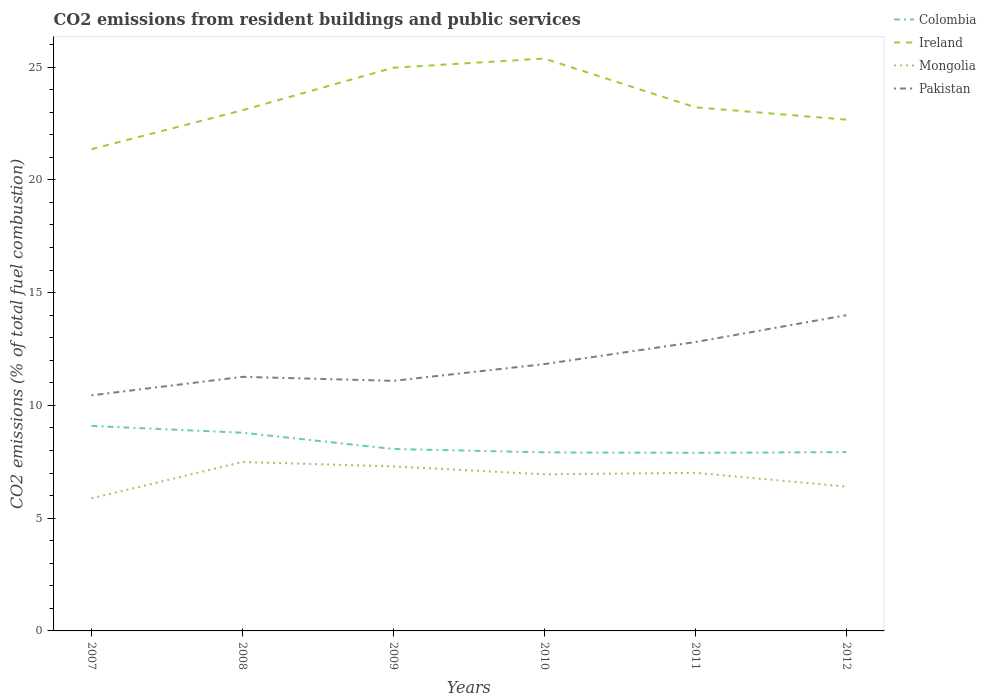How many different coloured lines are there?
Make the answer very short. 4. Does the line corresponding to Pakistan intersect with the line corresponding to Colombia?
Offer a terse response. No. Across all years, what is the maximum total CO2 emitted in Pakistan?
Your answer should be very brief. 10.45. In which year was the total CO2 emitted in Ireland maximum?
Give a very brief answer. 2007. What is the total total CO2 emitted in Colombia in the graph?
Offer a terse response. 1.02. What is the difference between the highest and the second highest total CO2 emitted in Pakistan?
Offer a terse response. 3.55. Is the total CO2 emitted in Colombia strictly greater than the total CO2 emitted in Ireland over the years?
Your answer should be compact. Yes. How many lines are there?
Make the answer very short. 4. How many years are there in the graph?
Provide a succinct answer. 6. What is the difference between two consecutive major ticks on the Y-axis?
Ensure brevity in your answer.  5. Does the graph contain any zero values?
Offer a terse response. No. Where does the legend appear in the graph?
Offer a very short reply. Top right. What is the title of the graph?
Keep it short and to the point. CO2 emissions from resident buildings and public services. What is the label or title of the Y-axis?
Your response must be concise. CO2 emissions (% of total fuel combustion). What is the CO2 emissions (% of total fuel combustion) in Colombia in 2007?
Give a very brief answer. 9.09. What is the CO2 emissions (% of total fuel combustion) of Ireland in 2007?
Give a very brief answer. 21.36. What is the CO2 emissions (% of total fuel combustion) of Mongolia in 2007?
Your response must be concise. 5.88. What is the CO2 emissions (% of total fuel combustion) in Pakistan in 2007?
Offer a very short reply. 10.45. What is the CO2 emissions (% of total fuel combustion) in Colombia in 2008?
Offer a very short reply. 8.79. What is the CO2 emissions (% of total fuel combustion) of Ireland in 2008?
Offer a very short reply. 23.09. What is the CO2 emissions (% of total fuel combustion) in Mongolia in 2008?
Provide a short and direct response. 7.49. What is the CO2 emissions (% of total fuel combustion) in Pakistan in 2008?
Your answer should be very brief. 11.27. What is the CO2 emissions (% of total fuel combustion) of Colombia in 2009?
Your answer should be very brief. 8.07. What is the CO2 emissions (% of total fuel combustion) of Ireland in 2009?
Provide a short and direct response. 24.97. What is the CO2 emissions (% of total fuel combustion) in Mongolia in 2009?
Make the answer very short. 7.3. What is the CO2 emissions (% of total fuel combustion) of Pakistan in 2009?
Make the answer very short. 11.09. What is the CO2 emissions (% of total fuel combustion) in Colombia in 2010?
Ensure brevity in your answer.  7.92. What is the CO2 emissions (% of total fuel combustion) in Ireland in 2010?
Provide a succinct answer. 25.38. What is the CO2 emissions (% of total fuel combustion) in Mongolia in 2010?
Your response must be concise. 6.94. What is the CO2 emissions (% of total fuel combustion) of Pakistan in 2010?
Your response must be concise. 11.83. What is the CO2 emissions (% of total fuel combustion) of Colombia in 2011?
Offer a terse response. 7.9. What is the CO2 emissions (% of total fuel combustion) of Ireland in 2011?
Provide a short and direct response. 23.22. What is the CO2 emissions (% of total fuel combustion) of Mongolia in 2011?
Give a very brief answer. 7.01. What is the CO2 emissions (% of total fuel combustion) in Pakistan in 2011?
Provide a succinct answer. 12.81. What is the CO2 emissions (% of total fuel combustion) in Colombia in 2012?
Your answer should be compact. 7.93. What is the CO2 emissions (% of total fuel combustion) of Ireland in 2012?
Offer a very short reply. 22.67. What is the CO2 emissions (% of total fuel combustion) in Mongolia in 2012?
Make the answer very short. 6.4. What is the CO2 emissions (% of total fuel combustion) of Pakistan in 2012?
Offer a very short reply. 14. Across all years, what is the maximum CO2 emissions (% of total fuel combustion) in Colombia?
Provide a succinct answer. 9.09. Across all years, what is the maximum CO2 emissions (% of total fuel combustion) of Ireland?
Offer a very short reply. 25.38. Across all years, what is the maximum CO2 emissions (% of total fuel combustion) of Mongolia?
Offer a terse response. 7.49. Across all years, what is the maximum CO2 emissions (% of total fuel combustion) in Pakistan?
Your response must be concise. 14. Across all years, what is the minimum CO2 emissions (% of total fuel combustion) of Colombia?
Provide a short and direct response. 7.9. Across all years, what is the minimum CO2 emissions (% of total fuel combustion) in Ireland?
Your response must be concise. 21.36. Across all years, what is the minimum CO2 emissions (% of total fuel combustion) of Mongolia?
Provide a succinct answer. 5.88. Across all years, what is the minimum CO2 emissions (% of total fuel combustion) of Pakistan?
Give a very brief answer. 10.45. What is the total CO2 emissions (% of total fuel combustion) of Colombia in the graph?
Ensure brevity in your answer.  49.69. What is the total CO2 emissions (% of total fuel combustion) in Ireland in the graph?
Offer a terse response. 140.69. What is the total CO2 emissions (% of total fuel combustion) of Mongolia in the graph?
Your answer should be very brief. 41.02. What is the total CO2 emissions (% of total fuel combustion) of Pakistan in the graph?
Your answer should be very brief. 71.44. What is the difference between the CO2 emissions (% of total fuel combustion) of Colombia in 2007 and that in 2008?
Keep it short and to the point. 0.3. What is the difference between the CO2 emissions (% of total fuel combustion) of Ireland in 2007 and that in 2008?
Keep it short and to the point. -1.73. What is the difference between the CO2 emissions (% of total fuel combustion) in Mongolia in 2007 and that in 2008?
Offer a terse response. -1.61. What is the difference between the CO2 emissions (% of total fuel combustion) in Pakistan in 2007 and that in 2008?
Offer a terse response. -0.82. What is the difference between the CO2 emissions (% of total fuel combustion) of Colombia in 2007 and that in 2009?
Your response must be concise. 1.02. What is the difference between the CO2 emissions (% of total fuel combustion) of Ireland in 2007 and that in 2009?
Provide a short and direct response. -3.61. What is the difference between the CO2 emissions (% of total fuel combustion) in Mongolia in 2007 and that in 2009?
Your response must be concise. -1.42. What is the difference between the CO2 emissions (% of total fuel combustion) of Pakistan in 2007 and that in 2009?
Provide a short and direct response. -0.64. What is the difference between the CO2 emissions (% of total fuel combustion) of Colombia in 2007 and that in 2010?
Offer a very short reply. 1.17. What is the difference between the CO2 emissions (% of total fuel combustion) in Ireland in 2007 and that in 2010?
Provide a succinct answer. -4.02. What is the difference between the CO2 emissions (% of total fuel combustion) of Mongolia in 2007 and that in 2010?
Your answer should be very brief. -1.07. What is the difference between the CO2 emissions (% of total fuel combustion) of Pakistan in 2007 and that in 2010?
Give a very brief answer. -1.38. What is the difference between the CO2 emissions (% of total fuel combustion) in Colombia in 2007 and that in 2011?
Offer a terse response. 1.19. What is the difference between the CO2 emissions (% of total fuel combustion) of Ireland in 2007 and that in 2011?
Your answer should be compact. -1.86. What is the difference between the CO2 emissions (% of total fuel combustion) of Mongolia in 2007 and that in 2011?
Your response must be concise. -1.13. What is the difference between the CO2 emissions (% of total fuel combustion) of Pakistan in 2007 and that in 2011?
Your answer should be compact. -2.36. What is the difference between the CO2 emissions (% of total fuel combustion) of Colombia in 2007 and that in 2012?
Your response must be concise. 1.16. What is the difference between the CO2 emissions (% of total fuel combustion) in Ireland in 2007 and that in 2012?
Ensure brevity in your answer.  -1.31. What is the difference between the CO2 emissions (% of total fuel combustion) in Mongolia in 2007 and that in 2012?
Offer a very short reply. -0.52. What is the difference between the CO2 emissions (% of total fuel combustion) of Pakistan in 2007 and that in 2012?
Give a very brief answer. -3.55. What is the difference between the CO2 emissions (% of total fuel combustion) of Colombia in 2008 and that in 2009?
Your response must be concise. 0.72. What is the difference between the CO2 emissions (% of total fuel combustion) in Ireland in 2008 and that in 2009?
Provide a succinct answer. -1.89. What is the difference between the CO2 emissions (% of total fuel combustion) in Mongolia in 2008 and that in 2009?
Your answer should be compact. 0.19. What is the difference between the CO2 emissions (% of total fuel combustion) in Pakistan in 2008 and that in 2009?
Ensure brevity in your answer.  0.18. What is the difference between the CO2 emissions (% of total fuel combustion) of Colombia in 2008 and that in 2010?
Give a very brief answer. 0.87. What is the difference between the CO2 emissions (% of total fuel combustion) of Ireland in 2008 and that in 2010?
Provide a succinct answer. -2.29. What is the difference between the CO2 emissions (% of total fuel combustion) of Mongolia in 2008 and that in 2010?
Offer a very short reply. 0.55. What is the difference between the CO2 emissions (% of total fuel combustion) of Pakistan in 2008 and that in 2010?
Your answer should be compact. -0.56. What is the difference between the CO2 emissions (% of total fuel combustion) of Colombia in 2008 and that in 2011?
Your answer should be very brief. 0.89. What is the difference between the CO2 emissions (% of total fuel combustion) in Ireland in 2008 and that in 2011?
Provide a succinct answer. -0.13. What is the difference between the CO2 emissions (% of total fuel combustion) in Mongolia in 2008 and that in 2011?
Your response must be concise. 0.48. What is the difference between the CO2 emissions (% of total fuel combustion) of Pakistan in 2008 and that in 2011?
Give a very brief answer. -1.54. What is the difference between the CO2 emissions (% of total fuel combustion) in Colombia in 2008 and that in 2012?
Make the answer very short. 0.86. What is the difference between the CO2 emissions (% of total fuel combustion) in Ireland in 2008 and that in 2012?
Give a very brief answer. 0.42. What is the difference between the CO2 emissions (% of total fuel combustion) in Mongolia in 2008 and that in 2012?
Your answer should be compact. 1.09. What is the difference between the CO2 emissions (% of total fuel combustion) of Pakistan in 2008 and that in 2012?
Make the answer very short. -2.73. What is the difference between the CO2 emissions (% of total fuel combustion) in Colombia in 2009 and that in 2010?
Your answer should be very brief. 0.15. What is the difference between the CO2 emissions (% of total fuel combustion) in Ireland in 2009 and that in 2010?
Your response must be concise. -0.4. What is the difference between the CO2 emissions (% of total fuel combustion) of Mongolia in 2009 and that in 2010?
Your answer should be very brief. 0.35. What is the difference between the CO2 emissions (% of total fuel combustion) of Pakistan in 2009 and that in 2010?
Provide a short and direct response. -0.74. What is the difference between the CO2 emissions (% of total fuel combustion) of Colombia in 2009 and that in 2011?
Your answer should be compact. 0.17. What is the difference between the CO2 emissions (% of total fuel combustion) of Ireland in 2009 and that in 2011?
Give a very brief answer. 1.76. What is the difference between the CO2 emissions (% of total fuel combustion) in Mongolia in 2009 and that in 2011?
Give a very brief answer. 0.29. What is the difference between the CO2 emissions (% of total fuel combustion) in Pakistan in 2009 and that in 2011?
Offer a terse response. -1.72. What is the difference between the CO2 emissions (% of total fuel combustion) of Colombia in 2009 and that in 2012?
Your answer should be very brief. 0.14. What is the difference between the CO2 emissions (% of total fuel combustion) in Ireland in 2009 and that in 2012?
Offer a very short reply. 2.3. What is the difference between the CO2 emissions (% of total fuel combustion) in Mongolia in 2009 and that in 2012?
Your answer should be compact. 0.9. What is the difference between the CO2 emissions (% of total fuel combustion) of Pakistan in 2009 and that in 2012?
Provide a succinct answer. -2.91. What is the difference between the CO2 emissions (% of total fuel combustion) in Colombia in 2010 and that in 2011?
Offer a terse response. 0.02. What is the difference between the CO2 emissions (% of total fuel combustion) in Ireland in 2010 and that in 2011?
Provide a succinct answer. 2.16. What is the difference between the CO2 emissions (% of total fuel combustion) of Mongolia in 2010 and that in 2011?
Keep it short and to the point. -0.07. What is the difference between the CO2 emissions (% of total fuel combustion) of Pakistan in 2010 and that in 2011?
Ensure brevity in your answer.  -0.98. What is the difference between the CO2 emissions (% of total fuel combustion) in Colombia in 2010 and that in 2012?
Keep it short and to the point. -0.01. What is the difference between the CO2 emissions (% of total fuel combustion) of Ireland in 2010 and that in 2012?
Your answer should be very brief. 2.71. What is the difference between the CO2 emissions (% of total fuel combustion) of Mongolia in 2010 and that in 2012?
Make the answer very short. 0.54. What is the difference between the CO2 emissions (% of total fuel combustion) of Pakistan in 2010 and that in 2012?
Ensure brevity in your answer.  -2.17. What is the difference between the CO2 emissions (% of total fuel combustion) in Colombia in 2011 and that in 2012?
Your answer should be very brief. -0.03. What is the difference between the CO2 emissions (% of total fuel combustion) of Ireland in 2011 and that in 2012?
Your response must be concise. 0.55. What is the difference between the CO2 emissions (% of total fuel combustion) of Mongolia in 2011 and that in 2012?
Provide a short and direct response. 0.61. What is the difference between the CO2 emissions (% of total fuel combustion) of Pakistan in 2011 and that in 2012?
Your answer should be very brief. -1.19. What is the difference between the CO2 emissions (% of total fuel combustion) in Colombia in 2007 and the CO2 emissions (% of total fuel combustion) in Ireland in 2008?
Keep it short and to the point. -14. What is the difference between the CO2 emissions (% of total fuel combustion) in Colombia in 2007 and the CO2 emissions (% of total fuel combustion) in Mongolia in 2008?
Provide a short and direct response. 1.6. What is the difference between the CO2 emissions (% of total fuel combustion) of Colombia in 2007 and the CO2 emissions (% of total fuel combustion) of Pakistan in 2008?
Make the answer very short. -2.18. What is the difference between the CO2 emissions (% of total fuel combustion) in Ireland in 2007 and the CO2 emissions (% of total fuel combustion) in Mongolia in 2008?
Provide a succinct answer. 13.87. What is the difference between the CO2 emissions (% of total fuel combustion) of Ireland in 2007 and the CO2 emissions (% of total fuel combustion) of Pakistan in 2008?
Provide a short and direct response. 10.09. What is the difference between the CO2 emissions (% of total fuel combustion) of Mongolia in 2007 and the CO2 emissions (% of total fuel combustion) of Pakistan in 2008?
Make the answer very short. -5.39. What is the difference between the CO2 emissions (% of total fuel combustion) in Colombia in 2007 and the CO2 emissions (% of total fuel combustion) in Ireland in 2009?
Keep it short and to the point. -15.89. What is the difference between the CO2 emissions (% of total fuel combustion) of Colombia in 2007 and the CO2 emissions (% of total fuel combustion) of Mongolia in 2009?
Your answer should be very brief. 1.79. What is the difference between the CO2 emissions (% of total fuel combustion) in Colombia in 2007 and the CO2 emissions (% of total fuel combustion) in Pakistan in 2009?
Provide a short and direct response. -2. What is the difference between the CO2 emissions (% of total fuel combustion) of Ireland in 2007 and the CO2 emissions (% of total fuel combustion) of Mongolia in 2009?
Make the answer very short. 14.06. What is the difference between the CO2 emissions (% of total fuel combustion) in Ireland in 2007 and the CO2 emissions (% of total fuel combustion) in Pakistan in 2009?
Ensure brevity in your answer.  10.27. What is the difference between the CO2 emissions (% of total fuel combustion) of Mongolia in 2007 and the CO2 emissions (% of total fuel combustion) of Pakistan in 2009?
Your answer should be very brief. -5.21. What is the difference between the CO2 emissions (% of total fuel combustion) in Colombia in 2007 and the CO2 emissions (% of total fuel combustion) in Ireland in 2010?
Provide a succinct answer. -16.29. What is the difference between the CO2 emissions (% of total fuel combustion) of Colombia in 2007 and the CO2 emissions (% of total fuel combustion) of Mongolia in 2010?
Your response must be concise. 2.15. What is the difference between the CO2 emissions (% of total fuel combustion) in Colombia in 2007 and the CO2 emissions (% of total fuel combustion) in Pakistan in 2010?
Your answer should be compact. -2.74. What is the difference between the CO2 emissions (% of total fuel combustion) of Ireland in 2007 and the CO2 emissions (% of total fuel combustion) of Mongolia in 2010?
Offer a terse response. 14.42. What is the difference between the CO2 emissions (% of total fuel combustion) of Ireland in 2007 and the CO2 emissions (% of total fuel combustion) of Pakistan in 2010?
Ensure brevity in your answer.  9.53. What is the difference between the CO2 emissions (% of total fuel combustion) in Mongolia in 2007 and the CO2 emissions (% of total fuel combustion) in Pakistan in 2010?
Your response must be concise. -5.95. What is the difference between the CO2 emissions (% of total fuel combustion) in Colombia in 2007 and the CO2 emissions (% of total fuel combustion) in Ireland in 2011?
Offer a very short reply. -14.13. What is the difference between the CO2 emissions (% of total fuel combustion) in Colombia in 2007 and the CO2 emissions (% of total fuel combustion) in Mongolia in 2011?
Your response must be concise. 2.08. What is the difference between the CO2 emissions (% of total fuel combustion) of Colombia in 2007 and the CO2 emissions (% of total fuel combustion) of Pakistan in 2011?
Give a very brief answer. -3.72. What is the difference between the CO2 emissions (% of total fuel combustion) in Ireland in 2007 and the CO2 emissions (% of total fuel combustion) in Mongolia in 2011?
Provide a succinct answer. 14.35. What is the difference between the CO2 emissions (% of total fuel combustion) in Ireland in 2007 and the CO2 emissions (% of total fuel combustion) in Pakistan in 2011?
Offer a terse response. 8.55. What is the difference between the CO2 emissions (% of total fuel combustion) in Mongolia in 2007 and the CO2 emissions (% of total fuel combustion) in Pakistan in 2011?
Keep it short and to the point. -6.93. What is the difference between the CO2 emissions (% of total fuel combustion) in Colombia in 2007 and the CO2 emissions (% of total fuel combustion) in Ireland in 2012?
Your answer should be very brief. -13.58. What is the difference between the CO2 emissions (% of total fuel combustion) of Colombia in 2007 and the CO2 emissions (% of total fuel combustion) of Mongolia in 2012?
Offer a very short reply. 2.69. What is the difference between the CO2 emissions (% of total fuel combustion) in Colombia in 2007 and the CO2 emissions (% of total fuel combustion) in Pakistan in 2012?
Provide a short and direct response. -4.91. What is the difference between the CO2 emissions (% of total fuel combustion) of Ireland in 2007 and the CO2 emissions (% of total fuel combustion) of Mongolia in 2012?
Provide a succinct answer. 14.96. What is the difference between the CO2 emissions (% of total fuel combustion) of Ireland in 2007 and the CO2 emissions (% of total fuel combustion) of Pakistan in 2012?
Your response must be concise. 7.36. What is the difference between the CO2 emissions (% of total fuel combustion) in Mongolia in 2007 and the CO2 emissions (% of total fuel combustion) in Pakistan in 2012?
Your response must be concise. -8.12. What is the difference between the CO2 emissions (% of total fuel combustion) in Colombia in 2008 and the CO2 emissions (% of total fuel combustion) in Ireland in 2009?
Provide a short and direct response. -16.19. What is the difference between the CO2 emissions (% of total fuel combustion) in Colombia in 2008 and the CO2 emissions (% of total fuel combustion) in Mongolia in 2009?
Your answer should be compact. 1.49. What is the difference between the CO2 emissions (% of total fuel combustion) in Colombia in 2008 and the CO2 emissions (% of total fuel combustion) in Pakistan in 2009?
Ensure brevity in your answer.  -2.3. What is the difference between the CO2 emissions (% of total fuel combustion) in Ireland in 2008 and the CO2 emissions (% of total fuel combustion) in Mongolia in 2009?
Offer a terse response. 15.79. What is the difference between the CO2 emissions (% of total fuel combustion) of Ireland in 2008 and the CO2 emissions (% of total fuel combustion) of Pakistan in 2009?
Ensure brevity in your answer.  12. What is the difference between the CO2 emissions (% of total fuel combustion) of Mongolia in 2008 and the CO2 emissions (% of total fuel combustion) of Pakistan in 2009?
Offer a very short reply. -3.6. What is the difference between the CO2 emissions (% of total fuel combustion) of Colombia in 2008 and the CO2 emissions (% of total fuel combustion) of Ireland in 2010?
Give a very brief answer. -16.59. What is the difference between the CO2 emissions (% of total fuel combustion) in Colombia in 2008 and the CO2 emissions (% of total fuel combustion) in Mongolia in 2010?
Provide a succinct answer. 1.85. What is the difference between the CO2 emissions (% of total fuel combustion) in Colombia in 2008 and the CO2 emissions (% of total fuel combustion) in Pakistan in 2010?
Your response must be concise. -3.04. What is the difference between the CO2 emissions (% of total fuel combustion) of Ireland in 2008 and the CO2 emissions (% of total fuel combustion) of Mongolia in 2010?
Provide a short and direct response. 16.14. What is the difference between the CO2 emissions (% of total fuel combustion) of Ireland in 2008 and the CO2 emissions (% of total fuel combustion) of Pakistan in 2010?
Offer a very short reply. 11.26. What is the difference between the CO2 emissions (% of total fuel combustion) in Mongolia in 2008 and the CO2 emissions (% of total fuel combustion) in Pakistan in 2010?
Keep it short and to the point. -4.34. What is the difference between the CO2 emissions (% of total fuel combustion) of Colombia in 2008 and the CO2 emissions (% of total fuel combustion) of Ireland in 2011?
Make the answer very short. -14.43. What is the difference between the CO2 emissions (% of total fuel combustion) of Colombia in 2008 and the CO2 emissions (% of total fuel combustion) of Mongolia in 2011?
Your answer should be very brief. 1.78. What is the difference between the CO2 emissions (% of total fuel combustion) of Colombia in 2008 and the CO2 emissions (% of total fuel combustion) of Pakistan in 2011?
Offer a terse response. -4.02. What is the difference between the CO2 emissions (% of total fuel combustion) of Ireland in 2008 and the CO2 emissions (% of total fuel combustion) of Mongolia in 2011?
Provide a short and direct response. 16.08. What is the difference between the CO2 emissions (% of total fuel combustion) of Ireland in 2008 and the CO2 emissions (% of total fuel combustion) of Pakistan in 2011?
Provide a succinct answer. 10.28. What is the difference between the CO2 emissions (% of total fuel combustion) in Mongolia in 2008 and the CO2 emissions (% of total fuel combustion) in Pakistan in 2011?
Offer a very short reply. -5.32. What is the difference between the CO2 emissions (% of total fuel combustion) of Colombia in 2008 and the CO2 emissions (% of total fuel combustion) of Ireland in 2012?
Your answer should be compact. -13.88. What is the difference between the CO2 emissions (% of total fuel combustion) of Colombia in 2008 and the CO2 emissions (% of total fuel combustion) of Mongolia in 2012?
Offer a terse response. 2.39. What is the difference between the CO2 emissions (% of total fuel combustion) in Colombia in 2008 and the CO2 emissions (% of total fuel combustion) in Pakistan in 2012?
Offer a very short reply. -5.21. What is the difference between the CO2 emissions (% of total fuel combustion) in Ireland in 2008 and the CO2 emissions (% of total fuel combustion) in Mongolia in 2012?
Give a very brief answer. 16.69. What is the difference between the CO2 emissions (% of total fuel combustion) of Ireland in 2008 and the CO2 emissions (% of total fuel combustion) of Pakistan in 2012?
Offer a very short reply. 9.09. What is the difference between the CO2 emissions (% of total fuel combustion) of Mongolia in 2008 and the CO2 emissions (% of total fuel combustion) of Pakistan in 2012?
Provide a succinct answer. -6.51. What is the difference between the CO2 emissions (% of total fuel combustion) of Colombia in 2009 and the CO2 emissions (% of total fuel combustion) of Ireland in 2010?
Offer a terse response. -17.31. What is the difference between the CO2 emissions (% of total fuel combustion) in Colombia in 2009 and the CO2 emissions (% of total fuel combustion) in Mongolia in 2010?
Give a very brief answer. 1.12. What is the difference between the CO2 emissions (% of total fuel combustion) of Colombia in 2009 and the CO2 emissions (% of total fuel combustion) of Pakistan in 2010?
Keep it short and to the point. -3.76. What is the difference between the CO2 emissions (% of total fuel combustion) in Ireland in 2009 and the CO2 emissions (% of total fuel combustion) in Mongolia in 2010?
Ensure brevity in your answer.  18.03. What is the difference between the CO2 emissions (% of total fuel combustion) of Ireland in 2009 and the CO2 emissions (% of total fuel combustion) of Pakistan in 2010?
Keep it short and to the point. 13.14. What is the difference between the CO2 emissions (% of total fuel combustion) in Mongolia in 2009 and the CO2 emissions (% of total fuel combustion) in Pakistan in 2010?
Make the answer very short. -4.53. What is the difference between the CO2 emissions (% of total fuel combustion) in Colombia in 2009 and the CO2 emissions (% of total fuel combustion) in Ireland in 2011?
Ensure brevity in your answer.  -15.15. What is the difference between the CO2 emissions (% of total fuel combustion) in Colombia in 2009 and the CO2 emissions (% of total fuel combustion) in Mongolia in 2011?
Your response must be concise. 1.06. What is the difference between the CO2 emissions (% of total fuel combustion) of Colombia in 2009 and the CO2 emissions (% of total fuel combustion) of Pakistan in 2011?
Give a very brief answer. -4.74. What is the difference between the CO2 emissions (% of total fuel combustion) of Ireland in 2009 and the CO2 emissions (% of total fuel combustion) of Mongolia in 2011?
Provide a succinct answer. 17.96. What is the difference between the CO2 emissions (% of total fuel combustion) in Ireland in 2009 and the CO2 emissions (% of total fuel combustion) in Pakistan in 2011?
Provide a succinct answer. 12.17. What is the difference between the CO2 emissions (% of total fuel combustion) of Mongolia in 2009 and the CO2 emissions (% of total fuel combustion) of Pakistan in 2011?
Your answer should be compact. -5.51. What is the difference between the CO2 emissions (% of total fuel combustion) in Colombia in 2009 and the CO2 emissions (% of total fuel combustion) in Ireland in 2012?
Your answer should be compact. -14.6. What is the difference between the CO2 emissions (% of total fuel combustion) of Colombia in 2009 and the CO2 emissions (% of total fuel combustion) of Mongolia in 2012?
Offer a terse response. 1.67. What is the difference between the CO2 emissions (% of total fuel combustion) in Colombia in 2009 and the CO2 emissions (% of total fuel combustion) in Pakistan in 2012?
Provide a short and direct response. -5.93. What is the difference between the CO2 emissions (% of total fuel combustion) in Ireland in 2009 and the CO2 emissions (% of total fuel combustion) in Mongolia in 2012?
Ensure brevity in your answer.  18.58. What is the difference between the CO2 emissions (% of total fuel combustion) in Ireland in 2009 and the CO2 emissions (% of total fuel combustion) in Pakistan in 2012?
Your answer should be compact. 10.98. What is the difference between the CO2 emissions (% of total fuel combustion) in Mongolia in 2009 and the CO2 emissions (% of total fuel combustion) in Pakistan in 2012?
Your response must be concise. -6.7. What is the difference between the CO2 emissions (% of total fuel combustion) of Colombia in 2010 and the CO2 emissions (% of total fuel combustion) of Ireland in 2011?
Offer a very short reply. -15.3. What is the difference between the CO2 emissions (% of total fuel combustion) of Colombia in 2010 and the CO2 emissions (% of total fuel combustion) of Mongolia in 2011?
Offer a terse response. 0.91. What is the difference between the CO2 emissions (% of total fuel combustion) of Colombia in 2010 and the CO2 emissions (% of total fuel combustion) of Pakistan in 2011?
Offer a very short reply. -4.89. What is the difference between the CO2 emissions (% of total fuel combustion) in Ireland in 2010 and the CO2 emissions (% of total fuel combustion) in Mongolia in 2011?
Provide a short and direct response. 18.37. What is the difference between the CO2 emissions (% of total fuel combustion) in Ireland in 2010 and the CO2 emissions (% of total fuel combustion) in Pakistan in 2011?
Give a very brief answer. 12.57. What is the difference between the CO2 emissions (% of total fuel combustion) in Mongolia in 2010 and the CO2 emissions (% of total fuel combustion) in Pakistan in 2011?
Your response must be concise. -5.87. What is the difference between the CO2 emissions (% of total fuel combustion) in Colombia in 2010 and the CO2 emissions (% of total fuel combustion) in Ireland in 2012?
Ensure brevity in your answer.  -14.75. What is the difference between the CO2 emissions (% of total fuel combustion) of Colombia in 2010 and the CO2 emissions (% of total fuel combustion) of Mongolia in 2012?
Your response must be concise. 1.52. What is the difference between the CO2 emissions (% of total fuel combustion) of Colombia in 2010 and the CO2 emissions (% of total fuel combustion) of Pakistan in 2012?
Provide a short and direct response. -6.08. What is the difference between the CO2 emissions (% of total fuel combustion) of Ireland in 2010 and the CO2 emissions (% of total fuel combustion) of Mongolia in 2012?
Ensure brevity in your answer.  18.98. What is the difference between the CO2 emissions (% of total fuel combustion) in Ireland in 2010 and the CO2 emissions (% of total fuel combustion) in Pakistan in 2012?
Offer a very short reply. 11.38. What is the difference between the CO2 emissions (% of total fuel combustion) in Mongolia in 2010 and the CO2 emissions (% of total fuel combustion) in Pakistan in 2012?
Your answer should be very brief. -7.06. What is the difference between the CO2 emissions (% of total fuel combustion) of Colombia in 2011 and the CO2 emissions (% of total fuel combustion) of Ireland in 2012?
Your answer should be compact. -14.77. What is the difference between the CO2 emissions (% of total fuel combustion) of Colombia in 2011 and the CO2 emissions (% of total fuel combustion) of Mongolia in 2012?
Offer a terse response. 1.5. What is the difference between the CO2 emissions (% of total fuel combustion) in Colombia in 2011 and the CO2 emissions (% of total fuel combustion) in Pakistan in 2012?
Your answer should be very brief. -6.1. What is the difference between the CO2 emissions (% of total fuel combustion) in Ireland in 2011 and the CO2 emissions (% of total fuel combustion) in Mongolia in 2012?
Your answer should be very brief. 16.82. What is the difference between the CO2 emissions (% of total fuel combustion) of Ireland in 2011 and the CO2 emissions (% of total fuel combustion) of Pakistan in 2012?
Offer a terse response. 9.22. What is the difference between the CO2 emissions (% of total fuel combustion) in Mongolia in 2011 and the CO2 emissions (% of total fuel combustion) in Pakistan in 2012?
Give a very brief answer. -6.99. What is the average CO2 emissions (% of total fuel combustion) in Colombia per year?
Provide a succinct answer. 8.28. What is the average CO2 emissions (% of total fuel combustion) in Ireland per year?
Your response must be concise. 23.45. What is the average CO2 emissions (% of total fuel combustion) of Mongolia per year?
Your response must be concise. 6.84. What is the average CO2 emissions (% of total fuel combustion) in Pakistan per year?
Give a very brief answer. 11.91. In the year 2007, what is the difference between the CO2 emissions (% of total fuel combustion) in Colombia and CO2 emissions (% of total fuel combustion) in Ireland?
Offer a very short reply. -12.27. In the year 2007, what is the difference between the CO2 emissions (% of total fuel combustion) in Colombia and CO2 emissions (% of total fuel combustion) in Mongolia?
Provide a short and direct response. 3.21. In the year 2007, what is the difference between the CO2 emissions (% of total fuel combustion) in Colombia and CO2 emissions (% of total fuel combustion) in Pakistan?
Your answer should be compact. -1.36. In the year 2007, what is the difference between the CO2 emissions (% of total fuel combustion) in Ireland and CO2 emissions (% of total fuel combustion) in Mongolia?
Make the answer very short. 15.48. In the year 2007, what is the difference between the CO2 emissions (% of total fuel combustion) in Ireland and CO2 emissions (% of total fuel combustion) in Pakistan?
Offer a very short reply. 10.91. In the year 2007, what is the difference between the CO2 emissions (% of total fuel combustion) of Mongolia and CO2 emissions (% of total fuel combustion) of Pakistan?
Ensure brevity in your answer.  -4.57. In the year 2008, what is the difference between the CO2 emissions (% of total fuel combustion) in Colombia and CO2 emissions (% of total fuel combustion) in Ireland?
Provide a short and direct response. -14.3. In the year 2008, what is the difference between the CO2 emissions (% of total fuel combustion) in Colombia and CO2 emissions (% of total fuel combustion) in Mongolia?
Your answer should be compact. 1.3. In the year 2008, what is the difference between the CO2 emissions (% of total fuel combustion) in Colombia and CO2 emissions (% of total fuel combustion) in Pakistan?
Your answer should be compact. -2.48. In the year 2008, what is the difference between the CO2 emissions (% of total fuel combustion) of Ireland and CO2 emissions (% of total fuel combustion) of Mongolia?
Provide a short and direct response. 15.6. In the year 2008, what is the difference between the CO2 emissions (% of total fuel combustion) of Ireland and CO2 emissions (% of total fuel combustion) of Pakistan?
Your response must be concise. 11.82. In the year 2008, what is the difference between the CO2 emissions (% of total fuel combustion) of Mongolia and CO2 emissions (% of total fuel combustion) of Pakistan?
Your answer should be very brief. -3.78. In the year 2009, what is the difference between the CO2 emissions (% of total fuel combustion) of Colombia and CO2 emissions (% of total fuel combustion) of Ireland?
Your answer should be compact. -16.91. In the year 2009, what is the difference between the CO2 emissions (% of total fuel combustion) in Colombia and CO2 emissions (% of total fuel combustion) in Mongolia?
Your answer should be compact. 0.77. In the year 2009, what is the difference between the CO2 emissions (% of total fuel combustion) in Colombia and CO2 emissions (% of total fuel combustion) in Pakistan?
Your response must be concise. -3.02. In the year 2009, what is the difference between the CO2 emissions (% of total fuel combustion) of Ireland and CO2 emissions (% of total fuel combustion) of Mongolia?
Provide a succinct answer. 17.68. In the year 2009, what is the difference between the CO2 emissions (% of total fuel combustion) of Ireland and CO2 emissions (% of total fuel combustion) of Pakistan?
Your answer should be very brief. 13.88. In the year 2009, what is the difference between the CO2 emissions (% of total fuel combustion) of Mongolia and CO2 emissions (% of total fuel combustion) of Pakistan?
Make the answer very short. -3.79. In the year 2010, what is the difference between the CO2 emissions (% of total fuel combustion) of Colombia and CO2 emissions (% of total fuel combustion) of Ireland?
Offer a terse response. -17.46. In the year 2010, what is the difference between the CO2 emissions (% of total fuel combustion) of Colombia and CO2 emissions (% of total fuel combustion) of Mongolia?
Offer a terse response. 0.97. In the year 2010, what is the difference between the CO2 emissions (% of total fuel combustion) of Colombia and CO2 emissions (% of total fuel combustion) of Pakistan?
Make the answer very short. -3.91. In the year 2010, what is the difference between the CO2 emissions (% of total fuel combustion) of Ireland and CO2 emissions (% of total fuel combustion) of Mongolia?
Offer a very short reply. 18.44. In the year 2010, what is the difference between the CO2 emissions (% of total fuel combustion) of Ireland and CO2 emissions (% of total fuel combustion) of Pakistan?
Offer a very short reply. 13.55. In the year 2010, what is the difference between the CO2 emissions (% of total fuel combustion) in Mongolia and CO2 emissions (% of total fuel combustion) in Pakistan?
Offer a very short reply. -4.89. In the year 2011, what is the difference between the CO2 emissions (% of total fuel combustion) in Colombia and CO2 emissions (% of total fuel combustion) in Ireland?
Your response must be concise. -15.32. In the year 2011, what is the difference between the CO2 emissions (% of total fuel combustion) of Colombia and CO2 emissions (% of total fuel combustion) of Mongolia?
Offer a very short reply. 0.89. In the year 2011, what is the difference between the CO2 emissions (% of total fuel combustion) of Colombia and CO2 emissions (% of total fuel combustion) of Pakistan?
Make the answer very short. -4.91. In the year 2011, what is the difference between the CO2 emissions (% of total fuel combustion) of Ireland and CO2 emissions (% of total fuel combustion) of Mongolia?
Keep it short and to the point. 16.21. In the year 2011, what is the difference between the CO2 emissions (% of total fuel combustion) of Ireland and CO2 emissions (% of total fuel combustion) of Pakistan?
Ensure brevity in your answer.  10.41. In the year 2011, what is the difference between the CO2 emissions (% of total fuel combustion) in Mongolia and CO2 emissions (% of total fuel combustion) in Pakistan?
Offer a very short reply. -5.8. In the year 2012, what is the difference between the CO2 emissions (% of total fuel combustion) of Colombia and CO2 emissions (% of total fuel combustion) of Ireland?
Your answer should be very brief. -14.74. In the year 2012, what is the difference between the CO2 emissions (% of total fuel combustion) of Colombia and CO2 emissions (% of total fuel combustion) of Mongolia?
Offer a terse response. 1.53. In the year 2012, what is the difference between the CO2 emissions (% of total fuel combustion) of Colombia and CO2 emissions (% of total fuel combustion) of Pakistan?
Give a very brief answer. -6.07. In the year 2012, what is the difference between the CO2 emissions (% of total fuel combustion) in Ireland and CO2 emissions (% of total fuel combustion) in Mongolia?
Provide a succinct answer. 16.27. In the year 2012, what is the difference between the CO2 emissions (% of total fuel combustion) in Ireland and CO2 emissions (% of total fuel combustion) in Pakistan?
Give a very brief answer. 8.67. In the year 2012, what is the difference between the CO2 emissions (% of total fuel combustion) of Mongolia and CO2 emissions (% of total fuel combustion) of Pakistan?
Offer a terse response. -7.6. What is the ratio of the CO2 emissions (% of total fuel combustion) in Colombia in 2007 to that in 2008?
Make the answer very short. 1.03. What is the ratio of the CO2 emissions (% of total fuel combustion) of Ireland in 2007 to that in 2008?
Offer a terse response. 0.93. What is the ratio of the CO2 emissions (% of total fuel combustion) of Mongolia in 2007 to that in 2008?
Keep it short and to the point. 0.78. What is the ratio of the CO2 emissions (% of total fuel combustion) in Pakistan in 2007 to that in 2008?
Provide a short and direct response. 0.93. What is the ratio of the CO2 emissions (% of total fuel combustion) in Colombia in 2007 to that in 2009?
Offer a terse response. 1.13. What is the ratio of the CO2 emissions (% of total fuel combustion) of Ireland in 2007 to that in 2009?
Your answer should be compact. 0.86. What is the ratio of the CO2 emissions (% of total fuel combustion) of Mongolia in 2007 to that in 2009?
Your answer should be very brief. 0.81. What is the ratio of the CO2 emissions (% of total fuel combustion) of Pakistan in 2007 to that in 2009?
Keep it short and to the point. 0.94. What is the ratio of the CO2 emissions (% of total fuel combustion) in Colombia in 2007 to that in 2010?
Your answer should be very brief. 1.15. What is the ratio of the CO2 emissions (% of total fuel combustion) of Ireland in 2007 to that in 2010?
Keep it short and to the point. 0.84. What is the ratio of the CO2 emissions (% of total fuel combustion) of Mongolia in 2007 to that in 2010?
Offer a terse response. 0.85. What is the ratio of the CO2 emissions (% of total fuel combustion) in Pakistan in 2007 to that in 2010?
Keep it short and to the point. 0.88. What is the ratio of the CO2 emissions (% of total fuel combustion) in Colombia in 2007 to that in 2011?
Your response must be concise. 1.15. What is the ratio of the CO2 emissions (% of total fuel combustion) of Ireland in 2007 to that in 2011?
Your answer should be compact. 0.92. What is the ratio of the CO2 emissions (% of total fuel combustion) in Mongolia in 2007 to that in 2011?
Provide a succinct answer. 0.84. What is the ratio of the CO2 emissions (% of total fuel combustion) of Pakistan in 2007 to that in 2011?
Your answer should be very brief. 0.82. What is the ratio of the CO2 emissions (% of total fuel combustion) of Colombia in 2007 to that in 2012?
Keep it short and to the point. 1.15. What is the ratio of the CO2 emissions (% of total fuel combustion) in Ireland in 2007 to that in 2012?
Make the answer very short. 0.94. What is the ratio of the CO2 emissions (% of total fuel combustion) in Mongolia in 2007 to that in 2012?
Ensure brevity in your answer.  0.92. What is the ratio of the CO2 emissions (% of total fuel combustion) in Pakistan in 2007 to that in 2012?
Offer a terse response. 0.75. What is the ratio of the CO2 emissions (% of total fuel combustion) in Colombia in 2008 to that in 2009?
Your answer should be very brief. 1.09. What is the ratio of the CO2 emissions (% of total fuel combustion) in Ireland in 2008 to that in 2009?
Your answer should be compact. 0.92. What is the ratio of the CO2 emissions (% of total fuel combustion) in Mongolia in 2008 to that in 2009?
Your answer should be compact. 1.03. What is the ratio of the CO2 emissions (% of total fuel combustion) in Pakistan in 2008 to that in 2009?
Provide a succinct answer. 1.02. What is the ratio of the CO2 emissions (% of total fuel combustion) in Colombia in 2008 to that in 2010?
Your answer should be very brief. 1.11. What is the ratio of the CO2 emissions (% of total fuel combustion) in Ireland in 2008 to that in 2010?
Ensure brevity in your answer.  0.91. What is the ratio of the CO2 emissions (% of total fuel combustion) in Mongolia in 2008 to that in 2010?
Make the answer very short. 1.08. What is the ratio of the CO2 emissions (% of total fuel combustion) of Pakistan in 2008 to that in 2010?
Make the answer very short. 0.95. What is the ratio of the CO2 emissions (% of total fuel combustion) of Colombia in 2008 to that in 2011?
Your response must be concise. 1.11. What is the ratio of the CO2 emissions (% of total fuel combustion) of Ireland in 2008 to that in 2011?
Keep it short and to the point. 0.99. What is the ratio of the CO2 emissions (% of total fuel combustion) in Mongolia in 2008 to that in 2011?
Keep it short and to the point. 1.07. What is the ratio of the CO2 emissions (% of total fuel combustion) in Pakistan in 2008 to that in 2011?
Keep it short and to the point. 0.88. What is the ratio of the CO2 emissions (% of total fuel combustion) in Colombia in 2008 to that in 2012?
Provide a succinct answer. 1.11. What is the ratio of the CO2 emissions (% of total fuel combustion) of Ireland in 2008 to that in 2012?
Make the answer very short. 1.02. What is the ratio of the CO2 emissions (% of total fuel combustion) of Mongolia in 2008 to that in 2012?
Provide a succinct answer. 1.17. What is the ratio of the CO2 emissions (% of total fuel combustion) of Pakistan in 2008 to that in 2012?
Make the answer very short. 0.8. What is the ratio of the CO2 emissions (% of total fuel combustion) of Colombia in 2009 to that in 2010?
Your answer should be very brief. 1.02. What is the ratio of the CO2 emissions (% of total fuel combustion) in Ireland in 2009 to that in 2010?
Provide a succinct answer. 0.98. What is the ratio of the CO2 emissions (% of total fuel combustion) of Mongolia in 2009 to that in 2010?
Your answer should be very brief. 1.05. What is the ratio of the CO2 emissions (% of total fuel combustion) of Pakistan in 2009 to that in 2010?
Your answer should be very brief. 0.94. What is the ratio of the CO2 emissions (% of total fuel combustion) in Colombia in 2009 to that in 2011?
Ensure brevity in your answer.  1.02. What is the ratio of the CO2 emissions (% of total fuel combustion) in Ireland in 2009 to that in 2011?
Offer a terse response. 1.08. What is the ratio of the CO2 emissions (% of total fuel combustion) in Mongolia in 2009 to that in 2011?
Ensure brevity in your answer.  1.04. What is the ratio of the CO2 emissions (% of total fuel combustion) of Pakistan in 2009 to that in 2011?
Your answer should be compact. 0.87. What is the ratio of the CO2 emissions (% of total fuel combustion) in Colombia in 2009 to that in 2012?
Keep it short and to the point. 1.02. What is the ratio of the CO2 emissions (% of total fuel combustion) of Ireland in 2009 to that in 2012?
Ensure brevity in your answer.  1.1. What is the ratio of the CO2 emissions (% of total fuel combustion) of Mongolia in 2009 to that in 2012?
Provide a short and direct response. 1.14. What is the ratio of the CO2 emissions (% of total fuel combustion) in Pakistan in 2009 to that in 2012?
Provide a short and direct response. 0.79. What is the ratio of the CO2 emissions (% of total fuel combustion) of Colombia in 2010 to that in 2011?
Your response must be concise. 1. What is the ratio of the CO2 emissions (% of total fuel combustion) of Ireland in 2010 to that in 2011?
Offer a terse response. 1.09. What is the ratio of the CO2 emissions (% of total fuel combustion) of Pakistan in 2010 to that in 2011?
Your response must be concise. 0.92. What is the ratio of the CO2 emissions (% of total fuel combustion) of Ireland in 2010 to that in 2012?
Provide a short and direct response. 1.12. What is the ratio of the CO2 emissions (% of total fuel combustion) in Mongolia in 2010 to that in 2012?
Provide a short and direct response. 1.08. What is the ratio of the CO2 emissions (% of total fuel combustion) in Pakistan in 2010 to that in 2012?
Provide a short and direct response. 0.85. What is the ratio of the CO2 emissions (% of total fuel combustion) of Ireland in 2011 to that in 2012?
Offer a terse response. 1.02. What is the ratio of the CO2 emissions (% of total fuel combustion) of Mongolia in 2011 to that in 2012?
Ensure brevity in your answer.  1.1. What is the ratio of the CO2 emissions (% of total fuel combustion) in Pakistan in 2011 to that in 2012?
Make the answer very short. 0.92. What is the difference between the highest and the second highest CO2 emissions (% of total fuel combustion) of Colombia?
Provide a succinct answer. 0.3. What is the difference between the highest and the second highest CO2 emissions (% of total fuel combustion) in Ireland?
Your answer should be compact. 0.4. What is the difference between the highest and the second highest CO2 emissions (% of total fuel combustion) in Mongolia?
Provide a short and direct response. 0.19. What is the difference between the highest and the second highest CO2 emissions (% of total fuel combustion) in Pakistan?
Make the answer very short. 1.19. What is the difference between the highest and the lowest CO2 emissions (% of total fuel combustion) of Colombia?
Give a very brief answer. 1.19. What is the difference between the highest and the lowest CO2 emissions (% of total fuel combustion) of Ireland?
Offer a terse response. 4.02. What is the difference between the highest and the lowest CO2 emissions (% of total fuel combustion) in Mongolia?
Your answer should be compact. 1.61. What is the difference between the highest and the lowest CO2 emissions (% of total fuel combustion) of Pakistan?
Offer a terse response. 3.55. 